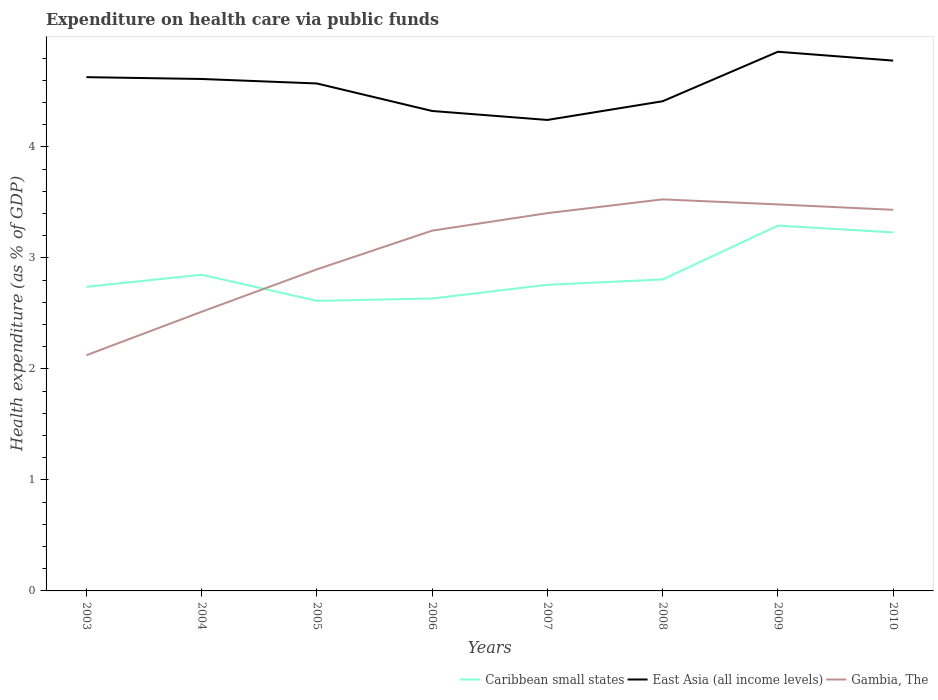Does the line corresponding to Caribbean small states intersect with the line corresponding to East Asia (all income levels)?
Your answer should be very brief. No. Is the number of lines equal to the number of legend labels?
Keep it short and to the point. Yes. Across all years, what is the maximum expenditure made on health care in East Asia (all income levels)?
Give a very brief answer. 4.24. What is the total expenditure made on health care in East Asia (all income levels) in the graph?
Provide a succinct answer. -0.09. What is the difference between the highest and the second highest expenditure made on health care in Gambia, The?
Provide a succinct answer. 1.4. What is the difference between the highest and the lowest expenditure made on health care in Gambia, The?
Give a very brief answer. 5. Does the graph contain any zero values?
Offer a very short reply. No. What is the title of the graph?
Your answer should be compact. Expenditure on health care via public funds. What is the label or title of the X-axis?
Ensure brevity in your answer.  Years. What is the label or title of the Y-axis?
Offer a terse response. Health expenditure (as % of GDP). What is the Health expenditure (as % of GDP) in Caribbean small states in 2003?
Offer a very short reply. 2.74. What is the Health expenditure (as % of GDP) in East Asia (all income levels) in 2003?
Provide a succinct answer. 4.63. What is the Health expenditure (as % of GDP) in Gambia, The in 2003?
Make the answer very short. 2.12. What is the Health expenditure (as % of GDP) in Caribbean small states in 2004?
Offer a terse response. 2.85. What is the Health expenditure (as % of GDP) of East Asia (all income levels) in 2004?
Provide a short and direct response. 4.61. What is the Health expenditure (as % of GDP) in Gambia, The in 2004?
Provide a succinct answer. 2.51. What is the Health expenditure (as % of GDP) in Caribbean small states in 2005?
Ensure brevity in your answer.  2.61. What is the Health expenditure (as % of GDP) in East Asia (all income levels) in 2005?
Offer a very short reply. 4.57. What is the Health expenditure (as % of GDP) in Gambia, The in 2005?
Keep it short and to the point. 2.9. What is the Health expenditure (as % of GDP) of Caribbean small states in 2006?
Offer a terse response. 2.63. What is the Health expenditure (as % of GDP) in East Asia (all income levels) in 2006?
Give a very brief answer. 4.32. What is the Health expenditure (as % of GDP) in Gambia, The in 2006?
Your answer should be compact. 3.25. What is the Health expenditure (as % of GDP) of Caribbean small states in 2007?
Keep it short and to the point. 2.76. What is the Health expenditure (as % of GDP) in East Asia (all income levels) in 2007?
Give a very brief answer. 4.24. What is the Health expenditure (as % of GDP) of Gambia, The in 2007?
Your answer should be very brief. 3.4. What is the Health expenditure (as % of GDP) in Caribbean small states in 2008?
Give a very brief answer. 2.81. What is the Health expenditure (as % of GDP) of East Asia (all income levels) in 2008?
Your response must be concise. 4.41. What is the Health expenditure (as % of GDP) in Gambia, The in 2008?
Give a very brief answer. 3.53. What is the Health expenditure (as % of GDP) of Caribbean small states in 2009?
Your answer should be very brief. 3.29. What is the Health expenditure (as % of GDP) of East Asia (all income levels) in 2009?
Your answer should be compact. 4.86. What is the Health expenditure (as % of GDP) in Gambia, The in 2009?
Give a very brief answer. 3.48. What is the Health expenditure (as % of GDP) in Caribbean small states in 2010?
Provide a succinct answer. 3.23. What is the Health expenditure (as % of GDP) in East Asia (all income levels) in 2010?
Your answer should be compact. 4.78. What is the Health expenditure (as % of GDP) in Gambia, The in 2010?
Offer a very short reply. 3.43. Across all years, what is the maximum Health expenditure (as % of GDP) of Caribbean small states?
Your answer should be compact. 3.29. Across all years, what is the maximum Health expenditure (as % of GDP) in East Asia (all income levels)?
Your response must be concise. 4.86. Across all years, what is the maximum Health expenditure (as % of GDP) in Gambia, The?
Your answer should be compact. 3.53. Across all years, what is the minimum Health expenditure (as % of GDP) of Caribbean small states?
Provide a short and direct response. 2.61. Across all years, what is the minimum Health expenditure (as % of GDP) in East Asia (all income levels)?
Your answer should be very brief. 4.24. Across all years, what is the minimum Health expenditure (as % of GDP) in Gambia, The?
Ensure brevity in your answer.  2.12. What is the total Health expenditure (as % of GDP) in Caribbean small states in the graph?
Provide a succinct answer. 22.92. What is the total Health expenditure (as % of GDP) in East Asia (all income levels) in the graph?
Your answer should be very brief. 36.42. What is the total Health expenditure (as % of GDP) of Gambia, The in the graph?
Ensure brevity in your answer.  24.63. What is the difference between the Health expenditure (as % of GDP) of Caribbean small states in 2003 and that in 2004?
Your response must be concise. -0.11. What is the difference between the Health expenditure (as % of GDP) of East Asia (all income levels) in 2003 and that in 2004?
Ensure brevity in your answer.  0.02. What is the difference between the Health expenditure (as % of GDP) of Gambia, The in 2003 and that in 2004?
Provide a short and direct response. -0.39. What is the difference between the Health expenditure (as % of GDP) of Caribbean small states in 2003 and that in 2005?
Your response must be concise. 0.13. What is the difference between the Health expenditure (as % of GDP) of East Asia (all income levels) in 2003 and that in 2005?
Keep it short and to the point. 0.06. What is the difference between the Health expenditure (as % of GDP) of Gambia, The in 2003 and that in 2005?
Make the answer very short. -0.77. What is the difference between the Health expenditure (as % of GDP) of Caribbean small states in 2003 and that in 2006?
Offer a terse response. 0.11. What is the difference between the Health expenditure (as % of GDP) in East Asia (all income levels) in 2003 and that in 2006?
Provide a succinct answer. 0.3. What is the difference between the Health expenditure (as % of GDP) in Gambia, The in 2003 and that in 2006?
Ensure brevity in your answer.  -1.12. What is the difference between the Health expenditure (as % of GDP) of Caribbean small states in 2003 and that in 2007?
Your response must be concise. -0.02. What is the difference between the Health expenditure (as % of GDP) in East Asia (all income levels) in 2003 and that in 2007?
Ensure brevity in your answer.  0.39. What is the difference between the Health expenditure (as % of GDP) in Gambia, The in 2003 and that in 2007?
Make the answer very short. -1.28. What is the difference between the Health expenditure (as % of GDP) of Caribbean small states in 2003 and that in 2008?
Make the answer very short. -0.07. What is the difference between the Health expenditure (as % of GDP) of East Asia (all income levels) in 2003 and that in 2008?
Keep it short and to the point. 0.22. What is the difference between the Health expenditure (as % of GDP) in Gambia, The in 2003 and that in 2008?
Provide a succinct answer. -1.4. What is the difference between the Health expenditure (as % of GDP) in Caribbean small states in 2003 and that in 2009?
Your answer should be very brief. -0.55. What is the difference between the Health expenditure (as % of GDP) of East Asia (all income levels) in 2003 and that in 2009?
Provide a short and direct response. -0.23. What is the difference between the Health expenditure (as % of GDP) in Gambia, The in 2003 and that in 2009?
Your response must be concise. -1.36. What is the difference between the Health expenditure (as % of GDP) of Caribbean small states in 2003 and that in 2010?
Keep it short and to the point. -0.49. What is the difference between the Health expenditure (as % of GDP) in East Asia (all income levels) in 2003 and that in 2010?
Give a very brief answer. -0.15. What is the difference between the Health expenditure (as % of GDP) in Gambia, The in 2003 and that in 2010?
Keep it short and to the point. -1.31. What is the difference between the Health expenditure (as % of GDP) of Caribbean small states in 2004 and that in 2005?
Offer a terse response. 0.24. What is the difference between the Health expenditure (as % of GDP) of East Asia (all income levels) in 2004 and that in 2005?
Give a very brief answer. 0.04. What is the difference between the Health expenditure (as % of GDP) of Gambia, The in 2004 and that in 2005?
Provide a short and direct response. -0.38. What is the difference between the Health expenditure (as % of GDP) of Caribbean small states in 2004 and that in 2006?
Your answer should be compact. 0.21. What is the difference between the Health expenditure (as % of GDP) in East Asia (all income levels) in 2004 and that in 2006?
Offer a terse response. 0.29. What is the difference between the Health expenditure (as % of GDP) of Gambia, The in 2004 and that in 2006?
Make the answer very short. -0.73. What is the difference between the Health expenditure (as % of GDP) of Caribbean small states in 2004 and that in 2007?
Provide a succinct answer. 0.09. What is the difference between the Health expenditure (as % of GDP) in East Asia (all income levels) in 2004 and that in 2007?
Keep it short and to the point. 0.37. What is the difference between the Health expenditure (as % of GDP) of Gambia, The in 2004 and that in 2007?
Your response must be concise. -0.89. What is the difference between the Health expenditure (as % of GDP) of Caribbean small states in 2004 and that in 2008?
Offer a very short reply. 0.04. What is the difference between the Health expenditure (as % of GDP) in East Asia (all income levels) in 2004 and that in 2008?
Make the answer very short. 0.2. What is the difference between the Health expenditure (as % of GDP) in Gambia, The in 2004 and that in 2008?
Your answer should be very brief. -1.01. What is the difference between the Health expenditure (as % of GDP) in Caribbean small states in 2004 and that in 2009?
Your response must be concise. -0.44. What is the difference between the Health expenditure (as % of GDP) of East Asia (all income levels) in 2004 and that in 2009?
Keep it short and to the point. -0.25. What is the difference between the Health expenditure (as % of GDP) in Gambia, The in 2004 and that in 2009?
Your answer should be compact. -0.97. What is the difference between the Health expenditure (as % of GDP) of Caribbean small states in 2004 and that in 2010?
Keep it short and to the point. -0.38. What is the difference between the Health expenditure (as % of GDP) in East Asia (all income levels) in 2004 and that in 2010?
Keep it short and to the point. -0.17. What is the difference between the Health expenditure (as % of GDP) in Gambia, The in 2004 and that in 2010?
Your answer should be compact. -0.92. What is the difference between the Health expenditure (as % of GDP) in Caribbean small states in 2005 and that in 2006?
Offer a terse response. -0.02. What is the difference between the Health expenditure (as % of GDP) of East Asia (all income levels) in 2005 and that in 2006?
Your answer should be very brief. 0.25. What is the difference between the Health expenditure (as % of GDP) in Gambia, The in 2005 and that in 2006?
Provide a succinct answer. -0.35. What is the difference between the Health expenditure (as % of GDP) in Caribbean small states in 2005 and that in 2007?
Provide a short and direct response. -0.14. What is the difference between the Health expenditure (as % of GDP) of East Asia (all income levels) in 2005 and that in 2007?
Offer a terse response. 0.33. What is the difference between the Health expenditure (as % of GDP) in Gambia, The in 2005 and that in 2007?
Provide a succinct answer. -0.51. What is the difference between the Health expenditure (as % of GDP) of Caribbean small states in 2005 and that in 2008?
Give a very brief answer. -0.19. What is the difference between the Health expenditure (as % of GDP) in East Asia (all income levels) in 2005 and that in 2008?
Offer a terse response. 0.16. What is the difference between the Health expenditure (as % of GDP) of Gambia, The in 2005 and that in 2008?
Ensure brevity in your answer.  -0.63. What is the difference between the Health expenditure (as % of GDP) in Caribbean small states in 2005 and that in 2009?
Your answer should be compact. -0.68. What is the difference between the Health expenditure (as % of GDP) in East Asia (all income levels) in 2005 and that in 2009?
Make the answer very short. -0.29. What is the difference between the Health expenditure (as % of GDP) of Gambia, The in 2005 and that in 2009?
Give a very brief answer. -0.58. What is the difference between the Health expenditure (as % of GDP) of Caribbean small states in 2005 and that in 2010?
Your response must be concise. -0.62. What is the difference between the Health expenditure (as % of GDP) of East Asia (all income levels) in 2005 and that in 2010?
Provide a short and direct response. -0.21. What is the difference between the Health expenditure (as % of GDP) of Gambia, The in 2005 and that in 2010?
Ensure brevity in your answer.  -0.54. What is the difference between the Health expenditure (as % of GDP) of Caribbean small states in 2006 and that in 2007?
Your answer should be very brief. -0.12. What is the difference between the Health expenditure (as % of GDP) of East Asia (all income levels) in 2006 and that in 2007?
Provide a short and direct response. 0.08. What is the difference between the Health expenditure (as % of GDP) in Gambia, The in 2006 and that in 2007?
Ensure brevity in your answer.  -0.16. What is the difference between the Health expenditure (as % of GDP) of Caribbean small states in 2006 and that in 2008?
Your answer should be compact. -0.17. What is the difference between the Health expenditure (as % of GDP) of East Asia (all income levels) in 2006 and that in 2008?
Provide a succinct answer. -0.09. What is the difference between the Health expenditure (as % of GDP) in Gambia, The in 2006 and that in 2008?
Give a very brief answer. -0.28. What is the difference between the Health expenditure (as % of GDP) in Caribbean small states in 2006 and that in 2009?
Your answer should be compact. -0.66. What is the difference between the Health expenditure (as % of GDP) in East Asia (all income levels) in 2006 and that in 2009?
Keep it short and to the point. -0.53. What is the difference between the Health expenditure (as % of GDP) of Gambia, The in 2006 and that in 2009?
Your answer should be compact. -0.24. What is the difference between the Health expenditure (as % of GDP) in Caribbean small states in 2006 and that in 2010?
Ensure brevity in your answer.  -0.6. What is the difference between the Health expenditure (as % of GDP) of East Asia (all income levels) in 2006 and that in 2010?
Ensure brevity in your answer.  -0.45. What is the difference between the Health expenditure (as % of GDP) of Gambia, The in 2006 and that in 2010?
Ensure brevity in your answer.  -0.19. What is the difference between the Health expenditure (as % of GDP) of Caribbean small states in 2007 and that in 2008?
Make the answer very short. -0.05. What is the difference between the Health expenditure (as % of GDP) of East Asia (all income levels) in 2007 and that in 2008?
Give a very brief answer. -0.17. What is the difference between the Health expenditure (as % of GDP) of Gambia, The in 2007 and that in 2008?
Your answer should be compact. -0.12. What is the difference between the Health expenditure (as % of GDP) in Caribbean small states in 2007 and that in 2009?
Your answer should be very brief. -0.53. What is the difference between the Health expenditure (as % of GDP) in East Asia (all income levels) in 2007 and that in 2009?
Provide a short and direct response. -0.61. What is the difference between the Health expenditure (as % of GDP) of Gambia, The in 2007 and that in 2009?
Provide a succinct answer. -0.08. What is the difference between the Health expenditure (as % of GDP) in Caribbean small states in 2007 and that in 2010?
Your response must be concise. -0.47. What is the difference between the Health expenditure (as % of GDP) of East Asia (all income levels) in 2007 and that in 2010?
Offer a terse response. -0.53. What is the difference between the Health expenditure (as % of GDP) of Gambia, The in 2007 and that in 2010?
Your answer should be very brief. -0.03. What is the difference between the Health expenditure (as % of GDP) in Caribbean small states in 2008 and that in 2009?
Your answer should be compact. -0.48. What is the difference between the Health expenditure (as % of GDP) in East Asia (all income levels) in 2008 and that in 2009?
Give a very brief answer. -0.45. What is the difference between the Health expenditure (as % of GDP) of Gambia, The in 2008 and that in 2009?
Give a very brief answer. 0.05. What is the difference between the Health expenditure (as % of GDP) in Caribbean small states in 2008 and that in 2010?
Keep it short and to the point. -0.42. What is the difference between the Health expenditure (as % of GDP) of East Asia (all income levels) in 2008 and that in 2010?
Ensure brevity in your answer.  -0.37. What is the difference between the Health expenditure (as % of GDP) of Gambia, The in 2008 and that in 2010?
Your response must be concise. 0.09. What is the difference between the Health expenditure (as % of GDP) of Caribbean small states in 2009 and that in 2010?
Provide a short and direct response. 0.06. What is the difference between the Health expenditure (as % of GDP) in East Asia (all income levels) in 2009 and that in 2010?
Keep it short and to the point. 0.08. What is the difference between the Health expenditure (as % of GDP) in Gambia, The in 2009 and that in 2010?
Your answer should be compact. 0.05. What is the difference between the Health expenditure (as % of GDP) in Caribbean small states in 2003 and the Health expenditure (as % of GDP) in East Asia (all income levels) in 2004?
Give a very brief answer. -1.87. What is the difference between the Health expenditure (as % of GDP) in Caribbean small states in 2003 and the Health expenditure (as % of GDP) in Gambia, The in 2004?
Make the answer very short. 0.22. What is the difference between the Health expenditure (as % of GDP) of East Asia (all income levels) in 2003 and the Health expenditure (as % of GDP) of Gambia, The in 2004?
Keep it short and to the point. 2.11. What is the difference between the Health expenditure (as % of GDP) of Caribbean small states in 2003 and the Health expenditure (as % of GDP) of East Asia (all income levels) in 2005?
Offer a terse response. -1.83. What is the difference between the Health expenditure (as % of GDP) of Caribbean small states in 2003 and the Health expenditure (as % of GDP) of Gambia, The in 2005?
Make the answer very short. -0.16. What is the difference between the Health expenditure (as % of GDP) of East Asia (all income levels) in 2003 and the Health expenditure (as % of GDP) of Gambia, The in 2005?
Keep it short and to the point. 1.73. What is the difference between the Health expenditure (as % of GDP) in Caribbean small states in 2003 and the Health expenditure (as % of GDP) in East Asia (all income levels) in 2006?
Give a very brief answer. -1.58. What is the difference between the Health expenditure (as % of GDP) of Caribbean small states in 2003 and the Health expenditure (as % of GDP) of Gambia, The in 2006?
Offer a terse response. -0.51. What is the difference between the Health expenditure (as % of GDP) of East Asia (all income levels) in 2003 and the Health expenditure (as % of GDP) of Gambia, The in 2006?
Offer a terse response. 1.38. What is the difference between the Health expenditure (as % of GDP) of Caribbean small states in 2003 and the Health expenditure (as % of GDP) of East Asia (all income levels) in 2007?
Offer a terse response. -1.5. What is the difference between the Health expenditure (as % of GDP) in Caribbean small states in 2003 and the Health expenditure (as % of GDP) in Gambia, The in 2007?
Offer a terse response. -0.66. What is the difference between the Health expenditure (as % of GDP) of East Asia (all income levels) in 2003 and the Health expenditure (as % of GDP) of Gambia, The in 2007?
Offer a very short reply. 1.23. What is the difference between the Health expenditure (as % of GDP) in Caribbean small states in 2003 and the Health expenditure (as % of GDP) in East Asia (all income levels) in 2008?
Your response must be concise. -1.67. What is the difference between the Health expenditure (as % of GDP) in Caribbean small states in 2003 and the Health expenditure (as % of GDP) in Gambia, The in 2008?
Provide a succinct answer. -0.79. What is the difference between the Health expenditure (as % of GDP) of East Asia (all income levels) in 2003 and the Health expenditure (as % of GDP) of Gambia, The in 2008?
Offer a terse response. 1.1. What is the difference between the Health expenditure (as % of GDP) of Caribbean small states in 2003 and the Health expenditure (as % of GDP) of East Asia (all income levels) in 2009?
Provide a succinct answer. -2.12. What is the difference between the Health expenditure (as % of GDP) of Caribbean small states in 2003 and the Health expenditure (as % of GDP) of Gambia, The in 2009?
Offer a very short reply. -0.74. What is the difference between the Health expenditure (as % of GDP) of East Asia (all income levels) in 2003 and the Health expenditure (as % of GDP) of Gambia, The in 2009?
Make the answer very short. 1.15. What is the difference between the Health expenditure (as % of GDP) of Caribbean small states in 2003 and the Health expenditure (as % of GDP) of East Asia (all income levels) in 2010?
Provide a short and direct response. -2.04. What is the difference between the Health expenditure (as % of GDP) of Caribbean small states in 2003 and the Health expenditure (as % of GDP) of Gambia, The in 2010?
Provide a short and direct response. -0.69. What is the difference between the Health expenditure (as % of GDP) of East Asia (all income levels) in 2003 and the Health expenditure (as % of GDP) of Gambia, The in 2010?
Offer a very short reply. 1.19. What is the difference between the Health expenditure (as % of GDP) of Caribbean small states in 2004 and the Health expenditure (as % of GDP) of East Asia (all income levels) in 2005?
Keep it short and to the point. -1.72. What is the difference between the Health expenditure (as % of GDP) of Caribbean small states in 2004 and the Health expenditure (as % of GDP) of Gambia, The in 2005?
Keep it short and to the point. -0.05. What is the difference between the Health expenditure (as % of GDP) of East Asia (all income levels) in 2004 and the Health expenditure (as % of GDP) of Gambia, The in 2005?
Provide a succinct answer. 1.71. What is the difference between the Health expenditure (as % of GDP) in Caribbean small states in 2004 and the Health expenditure (as % of GDP) in East Asia (all income levels) in 2006?
Provide a short and direct response. -1.48. What is the difference between the Health expenditure (as % of GDP) in Caribbean small states in 2004 and the Health expenditure (as % of GDP) in Gambia, The in 2006?
Offer a very short reply. -0.4. What is the difference between the Health expenditure (as % of GDP) in East Asia (all income levels) in 2004 and the Health expenditure (as % of GDP) in Gambia, The in 2006?
Offer a very short reply. 1.37. What is the difference between the Health expenditure (as % of GDP) in Caribbean small states in 2004 and the Health expenditure (as % of GDP) in East Asia (all income levels) in 2007?
Give a very brief answer. -1.39. What is the difference between the Health expenditure (as % of GDP) of Caribbean small states in 2004 and the Health expenditure (as % of GDP) of Gambia, The in 2007?
Give a very brief answer. -0.55. What is the difference between the Health expenditure (as % of GDP) of East Asia (all income levels) in 2004 and the Health expenditure (as % of GDP) of Gambia, The in 2007?
Give a very brief answer. 1.21. What is the difference between the Health expenditure (as % of GDP) of Caribbean small states in 2004 and the Health expenditure (as % of GDP) of East Asia (all income levels) in 2008?
Your response must be concise. -1.56. What is the difference between the Health expenditure (as % of GDP) of Caribbean small states in 2004 and the Health expenditure (as % of GDP) of Gambia, The in 2008?
Offer a very short reply. -0.68. What is the difference between the Health expenditure (as % of GDP) in East Asia (all income levels) in 2004 and the Health expenditure (as % of GDP) in Gambia, The in 2008?
Offer a very short reply. 1.08. What is the difference between the Health expenditure (as % of GDP) in Caribbean small states in 2004 and the Health expenditure (as % of GDP) in East Asia (all income levels) in 2009?
Provide a short and direct response. -2.01. What is the difference between the Health expenditure (as % of GDP) in Caribbean small states in 2004 and the Health expenditure (as % of GDP) in Gambia, The in 2009?
Offer a very short reply. -0.63. What is the difference between the Health expenditure (as % of GDP) in East Asia (all income levels) in 2004 and the Health expenditure (as % of GDP) in Gambia, The in 2009?
Ensure brevity in your answer.  1.13. What is the difference between the Health expenditure (as % of GDP) of Caribbean small states in 2004 and the Health expenditure (as % of GDP) of East Asia (all income levels) in 2010?
Offer a terse response. -1.93. What is the difference between the Health expenditure (as % of GDP) in Caribbean small states in 2004 and the Health expenditure (as % of GDP) in Gambia, The in 2010?
Provide a succinct answer. -0.58. What is the difference between the Health expenditure (as % of GDP) in East Asia (all income levels) in 2004 and the Health expenditure (as % of GDP) in Gambia, The in 2010?
Your answer should be very brief. 1.18. What is the difference between the Health expenditure (as % of GDP) in Caribbean small states in 2005 and the Health expenditure (as % of GDP) in East Asia (all income levels) in 2006?
Offer a terse response. -1.71. What is the difference between the Health expenditure (as % of GDP) in Caribbean small states in 2005 and the Health expenditure (as % of GDP) in Gambia, The in 2006?
Offer a terse response. -0.63. What is the difference between the Health expenditure (as % of GDP) in East Asia (all income levels) in 2005 and the Health expenditure (as % of GDP) in Gambia, The in 2006?
Your response must be concise. 1.33. What is the difference between the Health expenditure (as % of GDP) in Caribbean small states in 2005 and the Health expenditure (as % of GDP) in East Asia (all income levels) in 2007?
Give a very brief answer. -1.63. What is the difference between the Health expenditure (as % of GDP) in Caribbean small states in 2005 and the Health expenditure (as % of GDP) in Gambia, The in 2007?
Your answer should be compact. -0.79. What is the difference between the Health expenditure (as % of GDP) in East Asia (all income levels) in 2005 and the Health expenditure (as % of GDP) in Gambia, The in 2007?
Your answer should be very brief. 1.17. What is the difference between the Health expenditure (as % of GDP) in Caribbean small states in 2005 and the Health expenditure (as % of GDP) in East Asia (all income levels) in 2008?
Offer a terse response. -1.8. What is the difference between the Health expenditure (as % of GDP) of Caribbean small states in 2005 and the Health expenditure (as % of GDP) of Gambia, The in 2008?
Give a very brief answer. -0.91. What is the difference between the Health expenditure (as % of GDP) of East Asia (all income levels) in 2005 and the Health expenditure (as % of GDP) of Gambia, The in 2008?
Give a very brief answer. 1.04. What is the difference between the Health expenditure (as % of GDP) of Caribbean small states in 2005 and the Health expenditure (as % of GDP) of East Asia (all income levels) in 2009?
Your answer should be very brief. -2.24. What is the difference between the Health expenditure (as % of GDP) of Caribbean small states in 2005 and the Health expenditure (as % of GDP) of Gambia, The in 2009?
Provide a succinct answer. -0.87. What is the difference between the Health expenditure (as % of GDP) in East Asia (all income levels) in 2005 and the Health expenditure (as % of GDP) in Gambia, The in 2009?
Offer a terse response. 1.09. What is the difference between the Health expenditure (as % of GDP) of Caribbean small states in 2005 and the Health expenditure (as % of GDP) of East Asia (all income levels) in 2010?
Your response must be concise. -2.16. What is the difference between the Health expenditure (as % of GDP) in Caribbean small states in 2005 and the Health expenditure (as % of GDP) in Gambia, The in 2010?
Make the answer very short. -0.82. What is the difference between the Health expenditure (as % of GDP) in East Asia (all income levels) in 2005 and the Health expenditure (as % of GDP) in Gambia, The in 2010?
Ensure brevity in your answer.  1.14. What is the difference between the Health expenditure (as % of GDP) in Caribbean small states in 2006 and the Health expenditure (as % of GDP) in East Asia (all income levels) in 2007?
Offer a very short reply. -1.61. What is the difference between the Health expenditure (as % of GDP) of Caribbean small states in 2006 and the Health expenditure (as % of GDP) of Gambia, The in 2007?
Your response must be concise. -0.77. What is the difference between the Health expenditure (as % of GDP) in East Asia (all income levels) in 2006 and the Health expenditure (as % of GDP) in Gambia, The in 2007?
Provide a short and direct response. 0.92. What is the difference between the Health expenditure (as % of GDP) in Caribbean small states in 2006 and the Health expenditure (as % of GDP) in East Asia (all income levels) in 2008?
Make the answer very short. -1.78. What is the difference between the Health expenditure (as % of GDP) of Caribbean small states in 2006 and the Health expenditure (as % of GDP) of Gambia, The in 2008?
Provide a succinct answer. -0.89. What is the difference between the Health expenditure (as % of GDP) in East Asia (all income levels) in 2006 and the Health expenditure (as % of GDP) in Gambia, The in 2008?
Give a very brief answer. 0.8. What is the difference between the Health expenditure (as % of GDP) of Caribbean small states in 2006 and the Health expenditure (as % of GDP) of East Asia (all income levels) in 2009?
Your response must be concise. -2.22. What is the difference between the Health expenditure (as % of GDP) of Caribbean small states in 2006 and the Health expenditure (as % of GDP) of Gambia, The in 2009?
Give a very brief answer. -0.85. What is the difference between the Health expenditure (as % of GDP) in East Asia (all income levels) in 2006 and the Health expenditure (as % of GDP) in Gambia, The in 2009?
Provide a succinct answer. 0.84. What is the difference between the Health expenditure (as % of GDP) in Caribbean small states in 2006 and the Health expenditure (as % of GDP) in East Asia (all income levels) in 2010?
Your response must be concise. -2.14. What is the difference between the Health expenditure (as % of GDP) in Caribbean small states in 2006 and the Health expenditure (as % of GDP) in Gambia, The in 2010?
Provide a succinct answer. -0.8. What is the difference between the Health expenditure (as % of GDP) of East Asia (all income levels) in 2006 and the Health expenditure (as % of GDP) of Gambia, The in 2010?
Your answer should be very brief. 0.89. What is the difference between the Health expenditure (as % of GDP) of Caribbean small states in 2007 and the Health expenditure (as % of GDP) of East Asia (all income levels) in 2008?
Your response must be concise. -1.65. What is the difference between the Health expenditure (as % of GDP) of Caribbean small states in 2007 and the Health expenditure (as % of GDP) of Gambia, The in 2008?
Make the answer very short. -0.77. What is the difference between the Health expenditure (as % of GDP) of East Asia (all income levels) in 2007 and the Health expenditure (as % of GDP) of Gambia, The in 2008?
Ensure brevity in your answer.  0.72. What is the difference between the Health expenditure (as % of GDP) in Caribbean small states in 2007 and the Health expenditure (as % of GDP) in East Asia (all income levels) in 2009?
Offer a very short reply. -2.1. What is the difference between the Health expenditure (as % of GDP) in Caribbean small states in 2007 and the Health expenditure (as % of GDP) in Gambia, The in 2009?
Your response must be concise. -0.72. What is the difference between the Health expenditure (as % of GDP) of East Asia (all income levels) in 2007 and the Health expenditure (as % of GDP) of Gambia, The in 2009?
Your answer should be compact. 0.76. What is the difference between the Health expenditure (as % of GDP) of Caribbean small states in 2007 and the Health expenditure (as % of GDP) of East Asia (all income levels) in 2010?
Ensure brevity in your answer.  -2.02. What is the difference between the Health expenditure (as % of GDP) in Caribbean small states in 2007 and the Health expenditure (as % of GDP) in Gambia, The in 2010?
Give a very brief answer. -0.68. What is the difference between the Health expenditure (as % of GDP) in East Asia (all income levels) in 2007 and the Health expenditure (as % of GDP) in Gambia, The in 2010?
Your response must be concise. 0.81. What is the difference between the Health expenditure (as % of GDP) in Caribbean small states in 2008 and the Health expenditure (as % of GDP) in East Asia (all income levels) in 2009?
Provide a succinct answer. -2.05. What is the difference between the Health expenditure (as % of GDP) in Caribbean small states in 2008 and the Health expenditure (as % of GDP) in Gambia, The in 2009?
Keep it short and to the point. -0.68. What is the difference between the Health expenditure (as % of GDP) of East Asia (all income levels) in 2008 and the Health expenditure (as % of GDP) of Gambia, The in 2009?
Provide a succinct answer. 0.93. What is the difference between the Health expenditure (as % of GDP) in Caribbean small states in 2008 and the Health expenditure (as % of GDP) in East Asia (all income levels) in 2010?
Give a very brief answer. -1.97. What is the difference between the Health expenditure (as % of GDP) of Caribbean small states in 2008 and the Health expenditure (as % of GDP) of Gambia, The in 2010?
Give a very brief answer. -0.63. What is the difference between the Health expenditure (as % of GDP) of East Asia (all income levels) in 2008 and the Health expenditure (as % of GDP) of Gambia, The in 2010?
Provide a short and direct response. 0.98. What is the difference between the Health expenditure (as % of GDP) of Caribbean small states in 2009 and the Health expenditure (as % of GDP) of East Asia (all income levels) in 2010?
Provide a short and direct response. -1.49. What is the difference between the Health expenditure (as % of GDP) in Caribbean small states in 2009 and the Health expenditure (as % of GDP) in Gambia, The in 2010?
Make the answer very short. -0.14. What is the difference between the Health expenditure (as % of GDP) of East Asia (all income levels) in 2009 and the Health expenditure (as % of GDP) of Gambia, The in 2010?
Make the answer very short. 1.42. What is the average Health expenditure (as % of GDP) of Caribbean small states per year?
Keep it short and to the point. 2.87. What is the average Health expenditure (as % of GDP) of East Asia (all income levels) per year?
Your response must be concise. 4.55. What is the average Health expenditure (as % of GDP) in Gambia, The per year?
Your response must be concise. 3.08. In the year 2003, what is the difference between the Health expenditure (as % of GDP) of Caribbean small states and Health expenditure (as % of GDP) of East Asia (all income levels)?
Provide a short and direct response. -1.89. In the year 2003, what is the difference between the Health expenditure (as % of GDP) in Caribbean small states and Health expenditure (as % of GDP) in Gambia, The?
Keep it short and to the point. 0.62. In the year 2003, what is the difference between the Health expenditure (as % of GDP) of East Asia (all income levels) and Health expenditure (as % of GDP) of Gambia, The?
Make the answer very short. 2.51. In the year 2004, what is the difference between the Health expenditure (as % of GDP) of Caribbean small states and Health expenditure (as % of GDP) of East Asia (all income levels)?
Offer a very short reply. -1.76. In the year 2004, what is the difference between the Health expenditure (as % of GDP) in Caribbean small states and Health expenditure (as % of GDP) in Gambia, The?
Keep it short and to the point. 0.33. In the year 2004, what is the difference between the Health expenditure (as % of GDP) of East Asia (all income levels) and Health expenditure (as % of GDP) of Gambia, The?
Your answer should be very brief. 2.1. In the year 2005, what is the difference between the Health expenditure (as % of GDP) in Caribbean small states and Health expenditure (as % of GDP) in East Asia (all income levels)?
Offer a very short reply. -1.96. In the year 2005, what is the difference between the Health expenditure (as % of GDP) in Caribbean small states and Health expenditure (as % of GDP) in Gambia, The?
Provide a succinct answer. -0.28. In the year 2005, what is the difference between the Health expenditure (as % of GDP) of East Asia (all income levels) and Health expenditure (as % of GDP) of Gambia, The?
Give a very brief answer. 1.67. In the year 2006, what is the difference between the Health expenditure (as % of GDP) in Caribbean small states and Health expenditure (as % of GDP) in East Asia (all income levels)?
Offer a very short reply. -1.69. In the year 2006, what is the difference between the Health expenditure (as % of GDP) of Caribbean small states and Health expenditure (as % of GDP) of Gambia, The?
Your answer should be compact. -0.61. In the year 2006, what is the difference between the Health expenditure (as % of GDP) of East Asia (all income levels) and Health expenditure (as % of GDP) of Gambia, The?
Make the answer very short. 1.08. In the year 2007, what is the difference between the Health expenditure (as % of GDP) in Caribbean small states and Health expenditure (as % of GDP) in East Asia (all income levels)?
Offer a very short reply. -1.48. In the year 2007, what is the difference between the Health expenditure (as % of GDP) of Caribbean small states and Health expenditure (as % of GDP) of Gambia, The?
Make the answer very short. -0.65. In the year 2007, what is the difference between the Health expenditure (as % of GDP) of East Asia (all income levels) and Health expenditure (as % of GDP) of Gambia, The?
Your answer should be compact. 0.84. In the year 2008, what is the difference between the Health expenditure (as % of GDP) of Caribbean small states and Health expenditure (as % of GDP) of East Asia (all income levels)?
Provide a succinct answer. -1.61. In the year 2008, what is the difference between the Health expenditure (as % of GDP) of Caribbean small states and Health expenditure (as % of GDP) of Gambia, The?
Your answer should be very brief. -0.72. In the year 2008, what is the difference between the Health expenditure (as % of GDP) of East Asia (all income levels) and Health expenditure (as % of GDP) of Gambia, The?
Your response must be concise. 0.88. In the year 2009, what is the difference between the Health expenditure (as % of GDP) of Caribbean small states and Health expenditure (as % of GDP) of East Asia (all income levels)?
Ensure brevity in your answer.  -1.57. In the year 2009, what is the difference between the Health expenditure (as % of GDP) of Caribbean small states and Health expenditure (as % of GDP) of Gambia, The?
Keep it short and to the point. -0.19. In the year 2009, what is the difference between the Health expenditure (as % of GDP) in East Asia (all income levels) and Health expenditure (as % of GDP) in Gambia, The?
Provide a succinct answer. 1.38. In the year 2010, what is the difference between the Health expenditure (as % of GDP) in Caribbean small states and Health expenditure (as % of GDP) in East Asia (all income levels)?
Offer a very short reply. -1.55. In the year 2010, what is the difference between the Health expenditure (as % of GDP) in Caribbean small states and Health expenditure (as % of GDP) in Gambia, The?
Give a very brief answer. -0.2. In the year 2010, what is the difference between the Health expenditure (as % of GDP) of East Asia (all income levels) and Health expenditure (as % of GDP) of Gambia, The?
Offer a terse response. 1.34. What is the ratio of the Health expenditure (as % of GDP) in Caribbean small states in 2003 to that in 2004?
Your answer should be very brief. 0.96. What is the ratio of the Health expenditure (as % of GDP) of Gambia, The in 2003 to that in 2004?
Provide a short and direct response. 0.84. What is the ratio of the Health expenditure (as % of GDP) in Caribbean small states in 2003 to that in 2005?
Offer a terse response. 1.05. What is the ratio of the Health expenditure (as % of GDP) in East Asia (all income levels) in 2003 to that in 2005?
Make the answer very short. 1.01. What is the ratio of the Health expenditure (as % of GDP) in Gambia, The in 2003 to that in 2005?
Offer a very short reply. 0.73. What is the ratio of the Health expenditure (as % of GDP) of Caribbean small states in 2003 to that in 2006?
Provide a succinct answer. 1.04. What is the ratio of the Health expenditure (as % of GDP) in East Asia (all income levels) in 2003 to that in 2006?
Provide a succinct answer. 1.07. What is the ratio of the Health expenditure (as % of GDP) in Gambia, The in 2003 to that in 2006?
Your response must be concise. 0.65. What is the ratio of the Health expenditure (as % of GDP) of Caribbean small states in 2003 to that in 2007?
Ensure brevity in your answer.  0.99. What is the ratio of the Health expenditure (as % of GDP) in East Asia (all income levels) in 2003 to that in 2007?
Your response must be concise. 1.09. What is the ratio of the Health expenditure (as % of GDP) in Gambia, The in 2003 to that in 2007?
Offer a very short reply. 0.62. What is the ratio of the Health expenditure (as % of GDP) in Caribbean small states in 2003 to that in 2008?
Offer a very short reply. 0.98. What is the ratio of the Health expenditure (as % of GDP) of East Asia (all income levels) in 2003 to that in 2008?
Give a very brief answer. 1.05. What is the ratio of the Health expenditure (as % of GDP) in Gambia, The in 2003 to that in 2008?
Give a very brief answer. 0.6. What is the ratio of the Health expenditure (as % of GDP) in Caribbean small states in 2003 to that in 2009?
Ensure brevity in your answer.  0.83. What is the ratio of the Health expenditure (as % of GDP) of East Asia (all income levels) in 2003 to that in 2009?
Make the answer very short. 0.95. What is the ratio of the Health expenditure (as % of GDP) in Gambia, The in 2003 to that in 2009?
Provide a succinct answer. 0.61. What is the ratio of the Health expenditure (as % of GDP) of Caribbean small states in 2003 to that in 2010?
Offer a very short reply. 0.85. What is the ratio of the Health expenditure (as % of GDP) in East Asia (all income levels) in 2003 to that in 2010?
Your answer should be very brief. 0.97. What is the ratio of the Health expenditure (as % of GDP) in Gambia, The in 2003 to that in 2010?
Provide a succinct answer. 0.62. What is the ratio of the Health expenditure (as % of GDP) of Caribbean small states in 2004 to that in 2005?
Your answer should be very brief. 1.09. What is the ratio of the Health expenditure (as % of GDP) in East Asia (all income levels) in 2004 to that in 2005?
Provide a short and direct response. 1.01. What is the ratio of the Health expenditure (as % of GDP) in Gambia, The in 2004 to that in 2005?
Your response must be concise. 0.87. What is the ratio of the Health expenditure (as % of GDP) in Caribbean small states in 2004 to that in 2006?
Offer a terse response. 1.08. What is the ratio of the Health expenditure (as % of GDP) in East Asia (all income levels) in 2004 to that in 2006?
Give a very brief answer. 1.07. What is the ratio of the Health expenditure (as % of GDP) of Gambia, The in 2004 to that in 2006?
Ensure brevity in your answer.  0.77. What is the ratio of the Health expenditure (as % of GDP) in Caribbean small states in 2004 to that in 2007?
Your answer should be compact. 1.03. What is the ratio of the Health expenditure (as % of GDP) of East Asia (all income levels) in 2004 to that in 2007?
Offer a terse response. 1.09. What is the ratio of the Health expenditure (as % of GDP) of Gambia, The in 2004 to that in 2007?
Your answer should be very brief. 0.74. What is the ratio of the Health expenditure (as % of GDP) in Caribbean small states in 2004 to that in 2008?
Make the answer very short. 1.02. What is the ratio of the Health expenditure (as % of GDP) of East Asia (all income levels) in 2004 to that in 2008?
Give a very brief answer. 1.05. What is the ratio of the Health expenditure (as % of GDP) in Gambia, The in 2004 to that in 2008?
Offer a very short reply. 0.71. What is the ratio of the Health expenditure (as % of GDP) in Caribbean small states in 2004 to that in 2009?
Provide a succinct answer. 0.87. What is the ratio of the Health expenditure (as % of GDP) in East Asia (all income levels) in 2004 to that in 2009?
Provide a succinct answer. 0.95. What is the ratio of the Health expenditure (as % of GDP) of Gambia, The in 2004 to that in 2009?
Offer a terse response. 0.72. What is the ratio of the Health expenditure (as % of GDP) in Caribbean small states in 2004 to that in 2010?
Offer a terse response. 0.88. What is the ratio of the Health expenditure (as % of GDP) in East Asia (all income levels) in 2004 to that in 2010?
Provide a short and direct response. 0.97. What is the ratio of the Health expenditure (as % of GDP) of Gambia, The in 2004 to that in 2010?
Your response must be concise. 0.73. What is the ratio of the Health expenditure (as % of GDP) of East Asia (all income levels) in 2005 to that in 2006?
Provide a succinct answer. 1.06. What is the ratio of the Health expenditure (as % of GDP) in Gambia, The in 2005 to that in 2006?
Your answer should be compact. 0.89. What is the ratio of the Health expenditure (as % of GDP) in Caribbean small states in 2005 to that in 2007?
Provide a short and direct response. 0.95. What is the ratio of the Health expenditure (as % of GDP) in East Asia (all income levels) in 2005 to that in 2007?
Your answer should be very brief. 1.08. What is the ratio of the Health expenditure (as % of GDP) of Gambia, The in 2005 to that in 2007?
Keep it short and to the point. 0.85. What is the ratio of the Health expenditure (as % of GDP) of Caribbean small states in 2005 to that in 2008?
Give a very brief answer. 0.93. What is the ratio of the Health expenditure (as % of GDP) of East Asia (all income levels) in 2005 to that in 2008?
Your answer should be very brief. 1.04. What is the ratio of the Health expenditure (as % of GDP) of Gambia, The in 2005 to that in 2008?
Ensure brevity in your answer.  0.82. What is the ratio of the Health expenditure (as % of GDP) of Caribbean small states in 2005 to that in 2009?
Provide a succinct answer. 0.79. What is the ratio of the Health expenditure (as % of GDP) of Gambia, The in 2005 to that in 2009?
Make the answer very short. 0.83. What is the ratio of the Health expenditure (as % of GDP) of Caribbean small states in 2005 to that in 2010?
Offer a very short reply. 0.81. What is the ratio of the Health expenditure (as % of GDP) of East Asia (all income levels) in 2005 to that in 2010?
Your answer should be very brief. 0.96. What is the ratio of the Health expenditure (as % of GDP) in Gambia, The in 2005 to that in 2010?
Give a very brief answer. 0.84. What is the ratio of the Health expenditure (as % of GDP) of Caribbean small states in 2006 to that in 2007?
Provide a short and direct response. 0.96. What is the ratio of the Health expenditure (as % of GDP) of Gambia, The in 2006 to that in 2007?
Offer a terse response. 0.95. What is the ratio of the Health expenditure (as % of GDP) of Caribbean small states in 2006 to that in 2008?
Keep it short and to the point. 0.94. What is the ratio of the Health expenditure (as % of GDP) of East Asia (all income levels) in 2006 to that in 2008?
Offer a terse response. 0.98. What is the ratio of the Health expenditure (as % of GDP) in Gambia, The in 2006 to that in 2008?
Ensure brevity in your answer.  0.92. What is the ratio of the Health expenditure (as % of GDP) in Caribbean small states in 2006 to that in 2009?
Ensure brevity in your answer.  0.8. What is the ratio of the Health expenditure (as % of GDP) of East Asia (all income levels) in 2006 to that in 2009?
Offer a terse response. 0.89. What is the ratio of the Health expenditure (as % of GDP) in Gambia, The in 2006 to that in 2009?
Your answer should be very brief. 0.93. What is the ratio of the Health expenditure (as % of GDP) of Caribbean small states in 2006 to that in 2010?
Ensure brevity in your answer.  0.82. What is the ratio of the Health expenditure (as % of GDP) in East Asia (all income levels) in 2006 to that in 2010?
Your answer should be very brief. 0.91. What is the ratio of the Health expenditure (as % of GDP) of Gambia, The in 2006 to that in 2010?
Offer a terse response. 0.95. What is the ratio of the Health expenditure (as % of GDP) in Caribbean small states in 2007 to that in 2008?
Provide a succinct answer. 0.98. What is the ratio of the Health expenditure (as % of GDP) in East Asia (all income levels) in 2007 to that in 2008?
Your answer should be compact. 0.96. What is the ratio of the Health expenditure (as % of GDP) of Gambia, The in 2007 to that in 2008?
Ensure brevity in your answer.  0.96. What is the ratio of the Health expenditure (as % of GDP) of Caribbean small states in 2007 to that in 2009?
Make the answer very short. 0.84. What is the ratio of the Health expenditure (as % of GDP) in East Asia (all income levels) in 2007 to that in 2009?
Your answer should be compact. 0.87. What is the ratio of the Health expenditure (as % of GDP) of Gambia, The in 2007 to that in 2009?
Offer a terse response. 0.98. What is the ratio of the Health expenditure (as % of GDP) in Caribbean small states in 2007 to that in 2010?
Provide a succinct answer. 0.85. What is the ratio of the Health expenditure (as % of GDP) in East Asia (all income levels) in 2007 to that in 2010?
Your answer should be compact. 0.89. What is the ratio of the Health expenditure (as % of GDP) of Caribbean small states in 2008 to that in 2009?
Provide a short and direct response. 0.85. What is the ratio of the Health expenditure (as % of GDP) in East Asia (all income levels) in 2008 to that in 2009?
Your response must be concise. 0.91. What is the ratio of the Health expenditure (as % of GDP) of Gambia, The in 2008 to that in 2009?
Make the answer very short. 1.01. What is the ratio of the Health expenditure (as % of GDP) of Caribbean small states in 2008 to that in 2010?
Your response must be concise. 0.87. What is the ratio of the Health expenditure (as % of GDP) in East Asia (all income levels) in 2008 to that in 2010?
Provide a succinct answer. 0.92. What is the ratio of the Health expenditure (as % of GDP) of Gambia, The in 2008 to that in 2010?
Offer a terse response. 1.03. What is the ratio of the Health expenditure (as % of GDP) in Caribbean small states in 2009 to that in 2010?
Your answer should be compact. 1.02. What is the ratio of the Health expenditure (as % of GDP) in East Asia (all income levels) in 2009 to that in 2010?
Keep it short and to the point. 1.02. What is the ratio of the Health expenditure (as % of GDP) of Gambia, The in 2009 to that in 2010?
Provide a succinct answer. 1.01. What is the difference between the highest and the second highest Health expenditure (as % of GDP) in Caribbean small states?
Offer a very short reply. 0.06. What is the difference between the highest and the second highest Health expenditure (as % of GDP) in East Asia (all income levels)?
Make the answer very short. 0.08. What is the difference between the highest and the second highest Health expenditure (as % of GDP) of Gambia, The?
Your answer should be compact. 0.05. What is the difference between the highest and the lowest Health expenditure (as % of GDP) in Caribbean small states?
Your answer should be very brief. 0.68. What is the difference between the highest and the lowest Health expenditure (as % of GDP) in East Asia (all income levels)?
Make the answer very short. 0.61. What is the difference between the highest and the lowest Health expenditure (as % of GDP) of Gambia, The?
Provide a succinct answer. 1.4. 